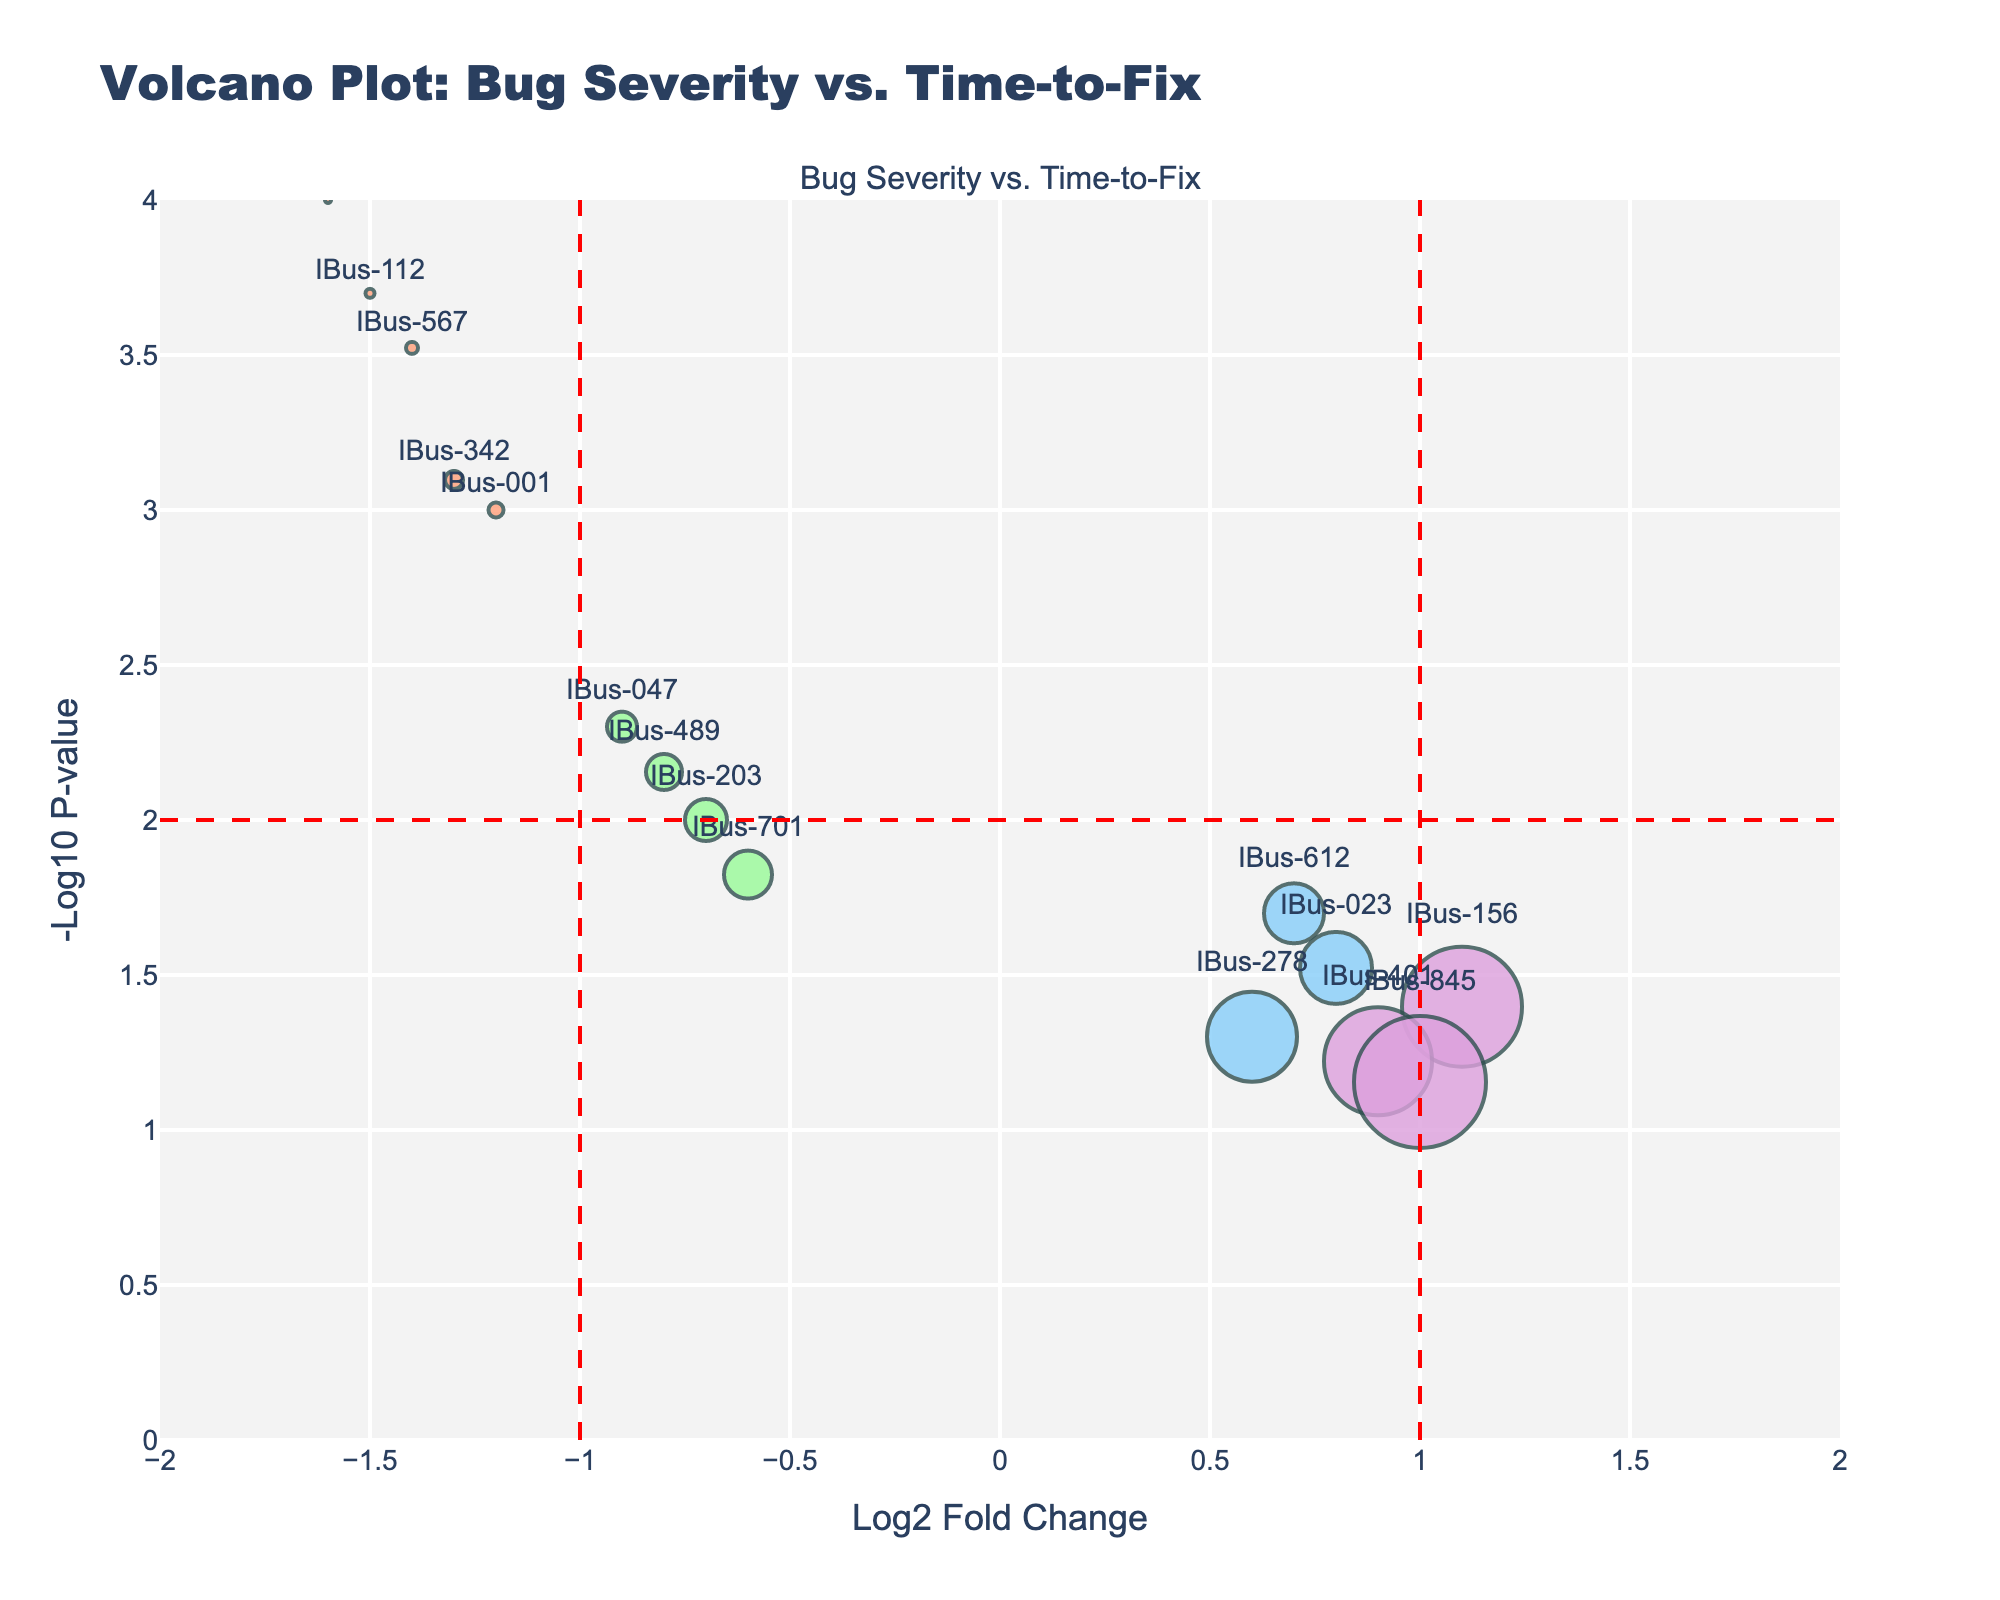What is the title of the figure? The title of the figure is located at the top center and is usually the most prominent text in the plot. It gives an overview of what the plot is about.
Answer: Volcano Plot: Bug Severity vs. Time-to-Fix What do the X and Y axes represent? The X-axis represents the Log2 Fold Change, and the Y-axis represents the -Log10 P-value. This is typically indicated by the axis labels.
Answer: X-axis: Log2 Fold Change, Y-axis: -Log10 P-value How many data points are there in total? Each point on the plot represents one bug. Count the number of markers or points visible on the plot to get the total number of data points.
Answer: 15 Which bug has the highest severity and the shortest time to fix? Look for the bug labeled "Critical" with the smallest circle size (indicating the shortest time to fix). Check the hover text in the plot for additional details.
Answer: IBus-789 How many bugs have a Log2 Fold Change greater than 1? Identify points on the right side of the vertical threshold line at Log2 Fold Change = 1. Only count those data points.
Answer: 3 Which bug has the lowest p-value? The bug with the lowest p-value will have the highest point on the Y-axis because the figure plots -Log10 P-value. Check the hover text of the highest point.
Answer: IBus-789 Compare the time-to-fix for bug IBus-023 and IBus-112. Which one is fixed quicker? Find the points for IBus-023 and IBus-112 on the plot. Compare their circle sizes (smaller size means quicker fix) or check the hover text for exact time-to-fix values.
Answer: IBus-112 Which severity level has the most outliers (bugs that stand out more prominently in the plot)? Look at the distribution of different colored points and determine which severity level has points that are further from the majority in terms of Log2 Fold Change and -Log10 P-value.
Answer: Critical What is the average time-to-fix for bugs with 'Major' severity? Identify the points with 'Major' severity. Sum their time-to-fix values and divide by the number of such bugs. Detailed calculations: (5 + 7 + 6 + 8) / 4 = 26 / 4 = 6.5
Answer: 6.5 Which severity level has bugs mostly with a negative Log2 Fold Change? Look for points on the left side of the X-axis (negative Log2 Fold Change) and check their colors or hover text for severity levels.
Answer: Critical 